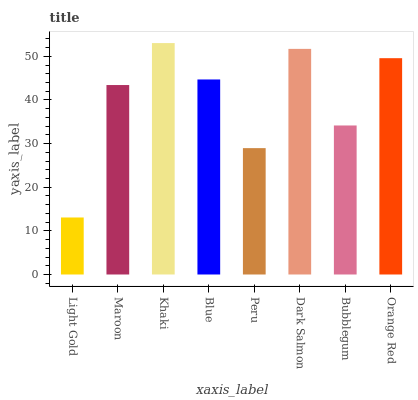Is Light Gold the minimum?
Answer yes or no. Yes. Is Khaki the maximum?
Answer yes or no. Yes. Is Maroon the minimum?
Answer yes or no. No. Is Maroon the maximum?
Answer yes or no. No. Is Maroon greater than Light Gold?
Answer yes or no. Yes. Is Light Gold less than Maroon?
Answer yes or no. Yes. Is Light Gold greater than Maroon?
Answer yes or no. No. Is Maroon less than Light Gold?
Answer yes or no. No. Is Blue the high median?
Answer yes or no. Yes. Is Maroon the low median?
Answer yes or no. Yes. Is Dark Salmon the high median?
Answer yes or no. No. Is Blue the low median?
Answer yes or no. No. 